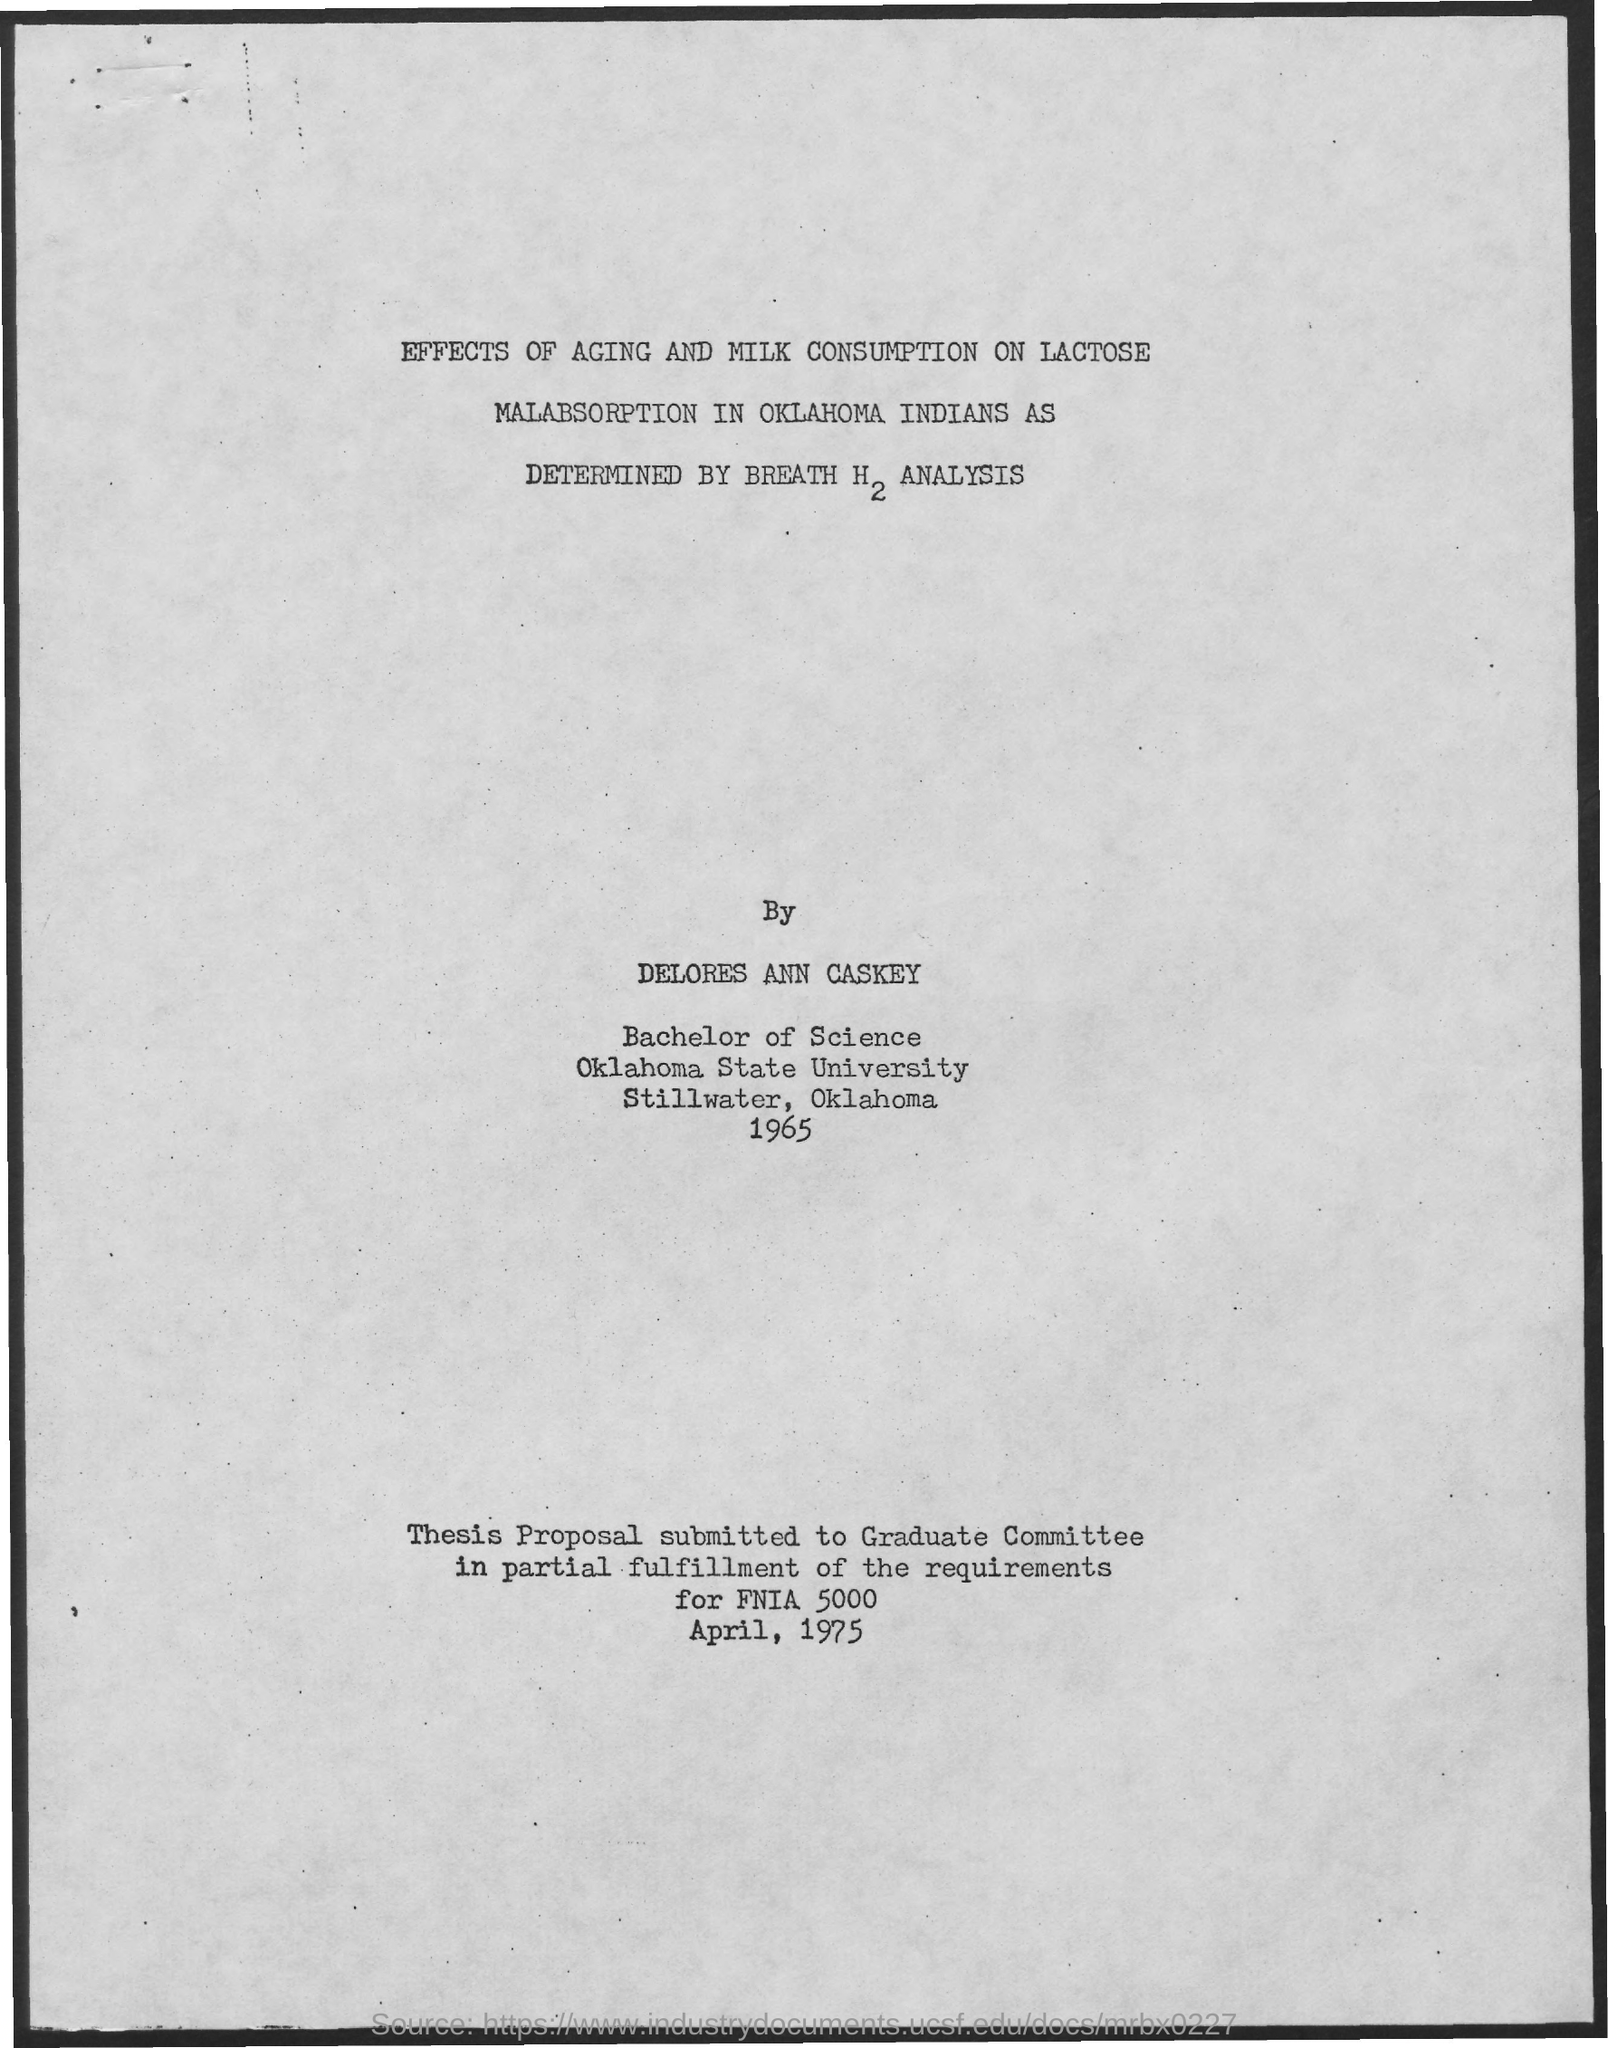Mention a couple of crucial points in this snapshot. I have submitted a thesis proposal to the Graduate Committee as a requirement for the completion of FNIA 5000. The thesis proposal is submitted to the Graduate Committee. 